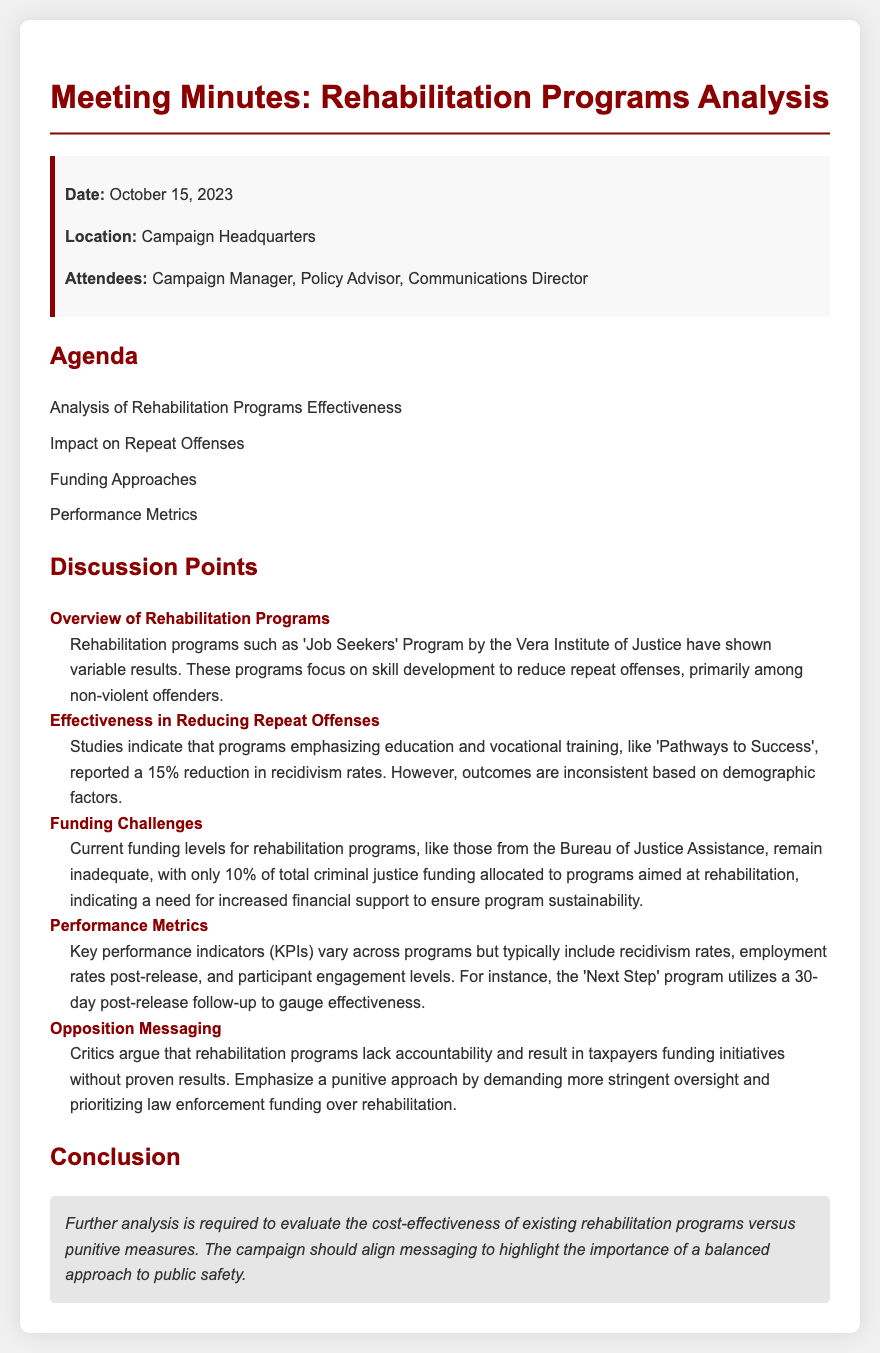What is the date of the meeting? The date of the meeting is stated at the beginning of the document.
Answer: October 15, 2023 Who attended the meeting? The document lists the attendees in the information box.
Answer: Campaign Manager, Policy Advisor, Communications Director What percentage of total criminal justice funding is allocated to rehabilitation programs? The funding challenges section specifies the allocation percentage.
Answer: 10% What program reported a 15% reduction in recidivism rates? The effectiveness section details which program had this result.
Answer: Pathways to Success What is one key performance indicator used in rehabilitation programs? The performance metrics discuss specific KPIs utilized by the programs.
Answer: Recidivism rates What criticism is mentioned regarding rehabilitation programs? The opposition messaging section highlights specific criticisms.
Answer: Lack of accountability What is the main focus of the 'Job Seekers' Program? The overview provides details about the program's primary goals.
Answer: Skill development What follow-up period does the 'Next Step' program use for assessing effectiveness? The performance metrics section states the time frame for follow-up.
Answer: 30-day post-release 